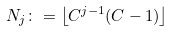<formula> <loc_0><loc_0><loc_500><loc_500>N _ { j } \colon = \left \lfloor C ^ { j - 1 } ( C - 1 ) \right \rfloor</formula> 